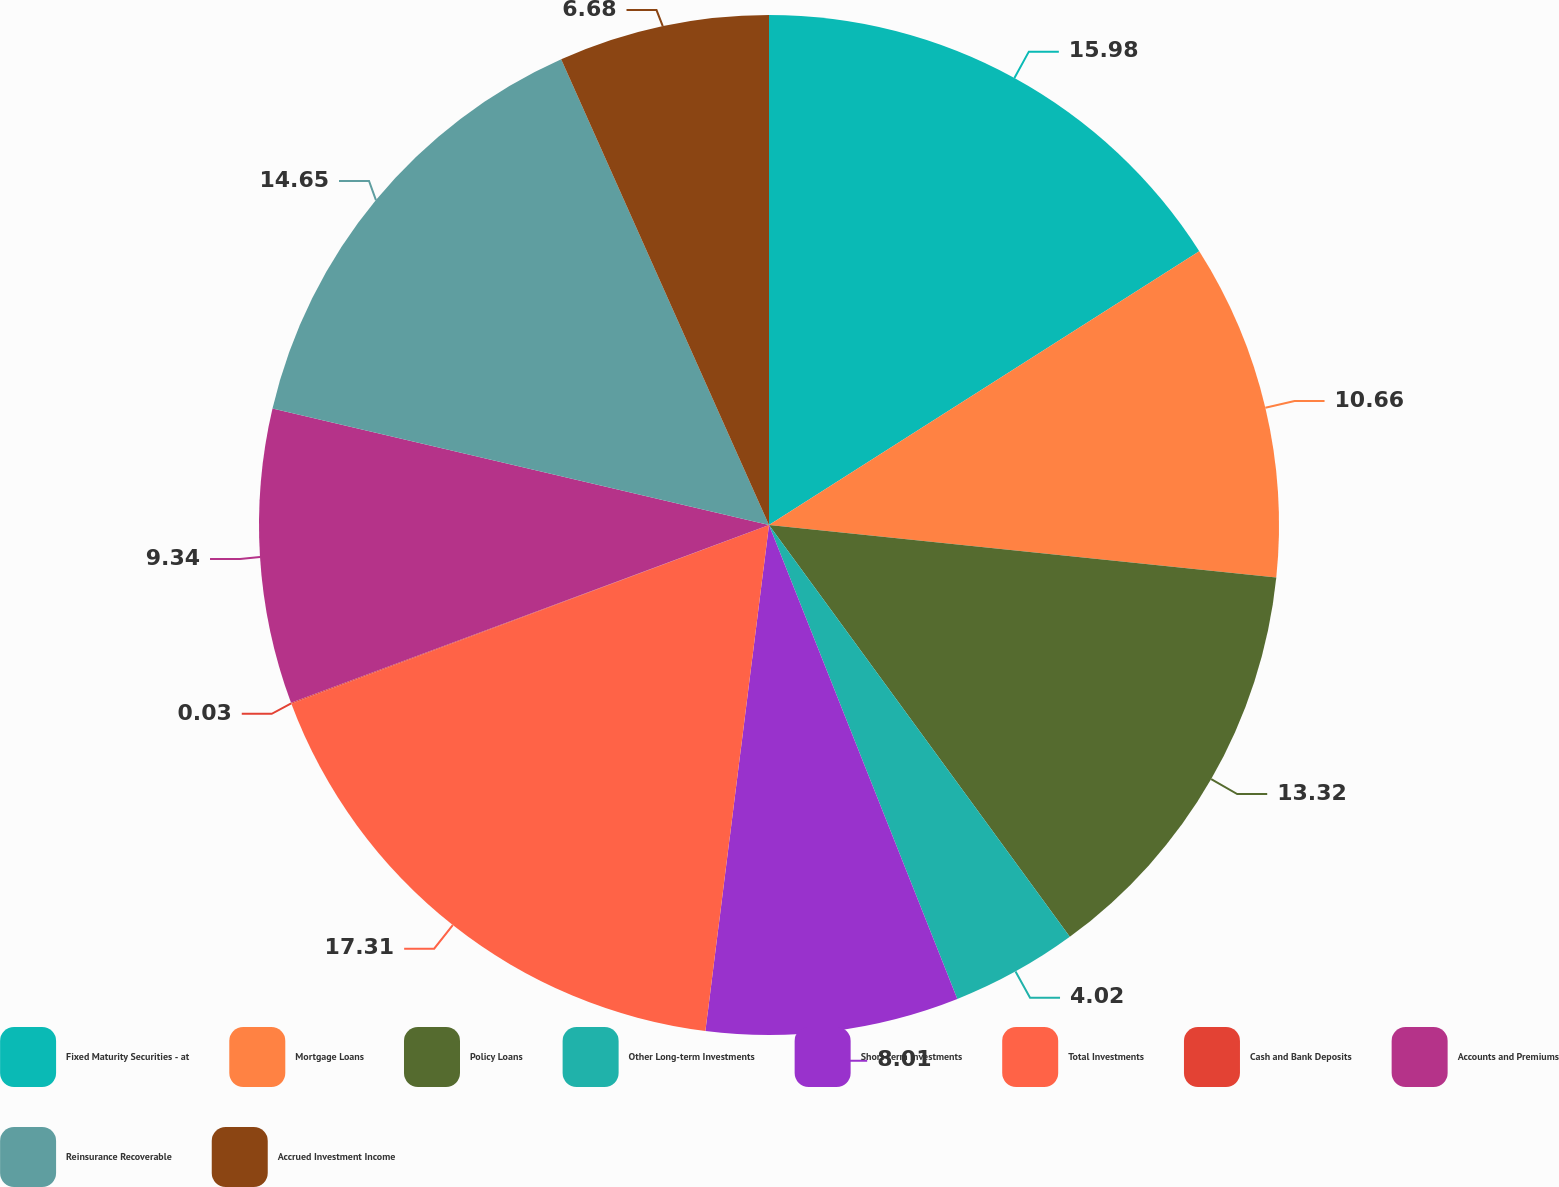Convert chart. <chart><loc_0><loc_0><loc_500><loc_500><pie_chart><fcel>Fixed Maturity Securities - at<fcel>Mortgage Loans<fcel>Policy Loans<fcel>Other Long-term Investments<fcel>Short-term Investments<fcel>Total Investments<fcel>Cash and Bank Deposits<fcel>Accounts and Premiums<fcel>Reinsurance Recoverable<fcel>Accrued Investment Income<nl><fcel>15.98%<fcel>10.66%<fcel>13.32%<fcel>4.02%<fcel>8.01%<fcel>17.31%<fcel>0.03%<fcel>9.34%<fcel>14.65%<fcel>6.68%<nl></chart> 